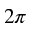<formula> <loc_0><loc_0><loc_500><loc_500>2 \pi</formula> 